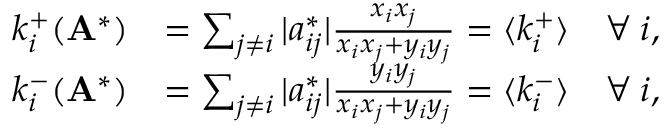<formula> <loc_0><loc_0><loc_500><loc_500>\begin{array} { r l } { k _ { i } ^ { + } ( A ^ { * } ) } & { = \sum _ { j \neq i } | a _ { i j } ^ { * } | \frac { x _ { i } x _ { j } } { x _ { i } x _ { j } + y _ { i } y _ { j } } = \langle k _ { i } ^ { + } \rangle \quad \forall \, i , } \\ { k _ { i } ^ { - } ( A ^ { * } ) } & { = \sum _ { j \neq i } | a _ { i j } ^ { * } | \frac { y _ { i } y _ { j } } { x _ { i } x _ { j } + y _ { i } y _ { j } } = \langle k _ { i } ^ { - } \rangle \quad \forall \, i , } \end{array}</formula> 